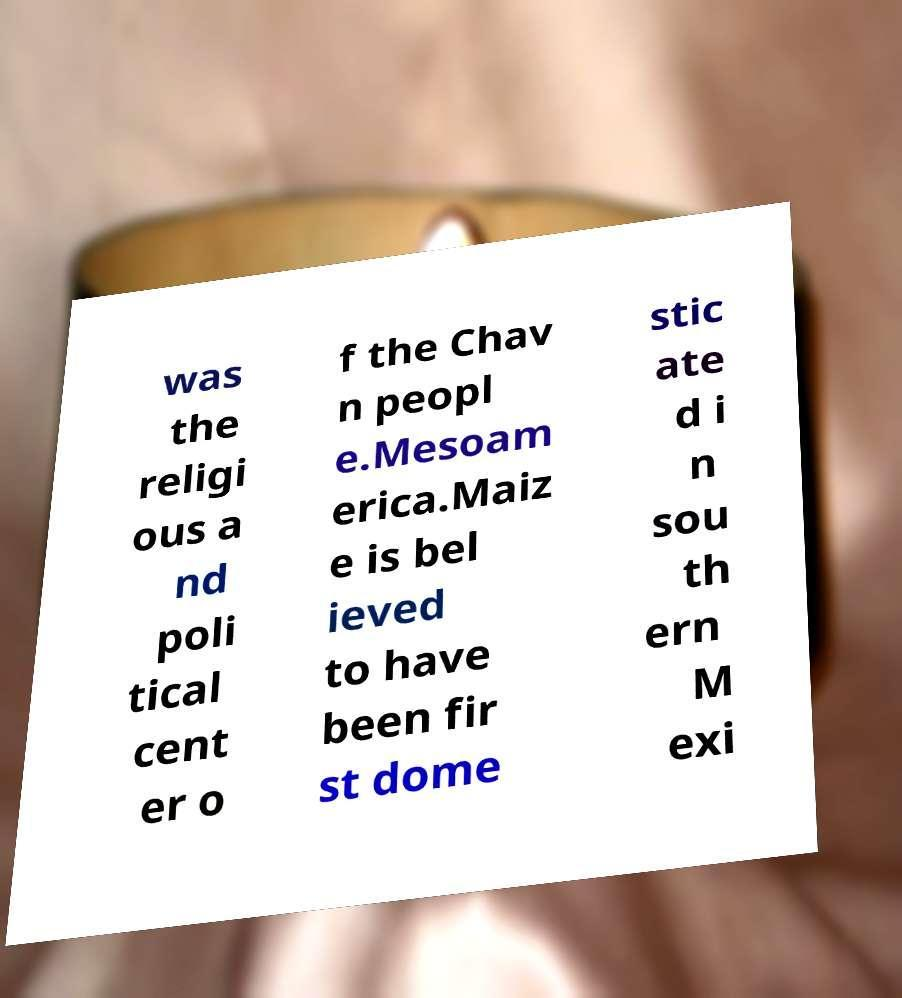There's text embedded in this image that I need extracted. Can you transcribe it verbatim? was the religi ous a nd poli tical cent er o f the Chav n peopl e.Mesoam erica.Maiz e is bel ieved to have been fir st dome stic ate d i n sou th ern M exi 